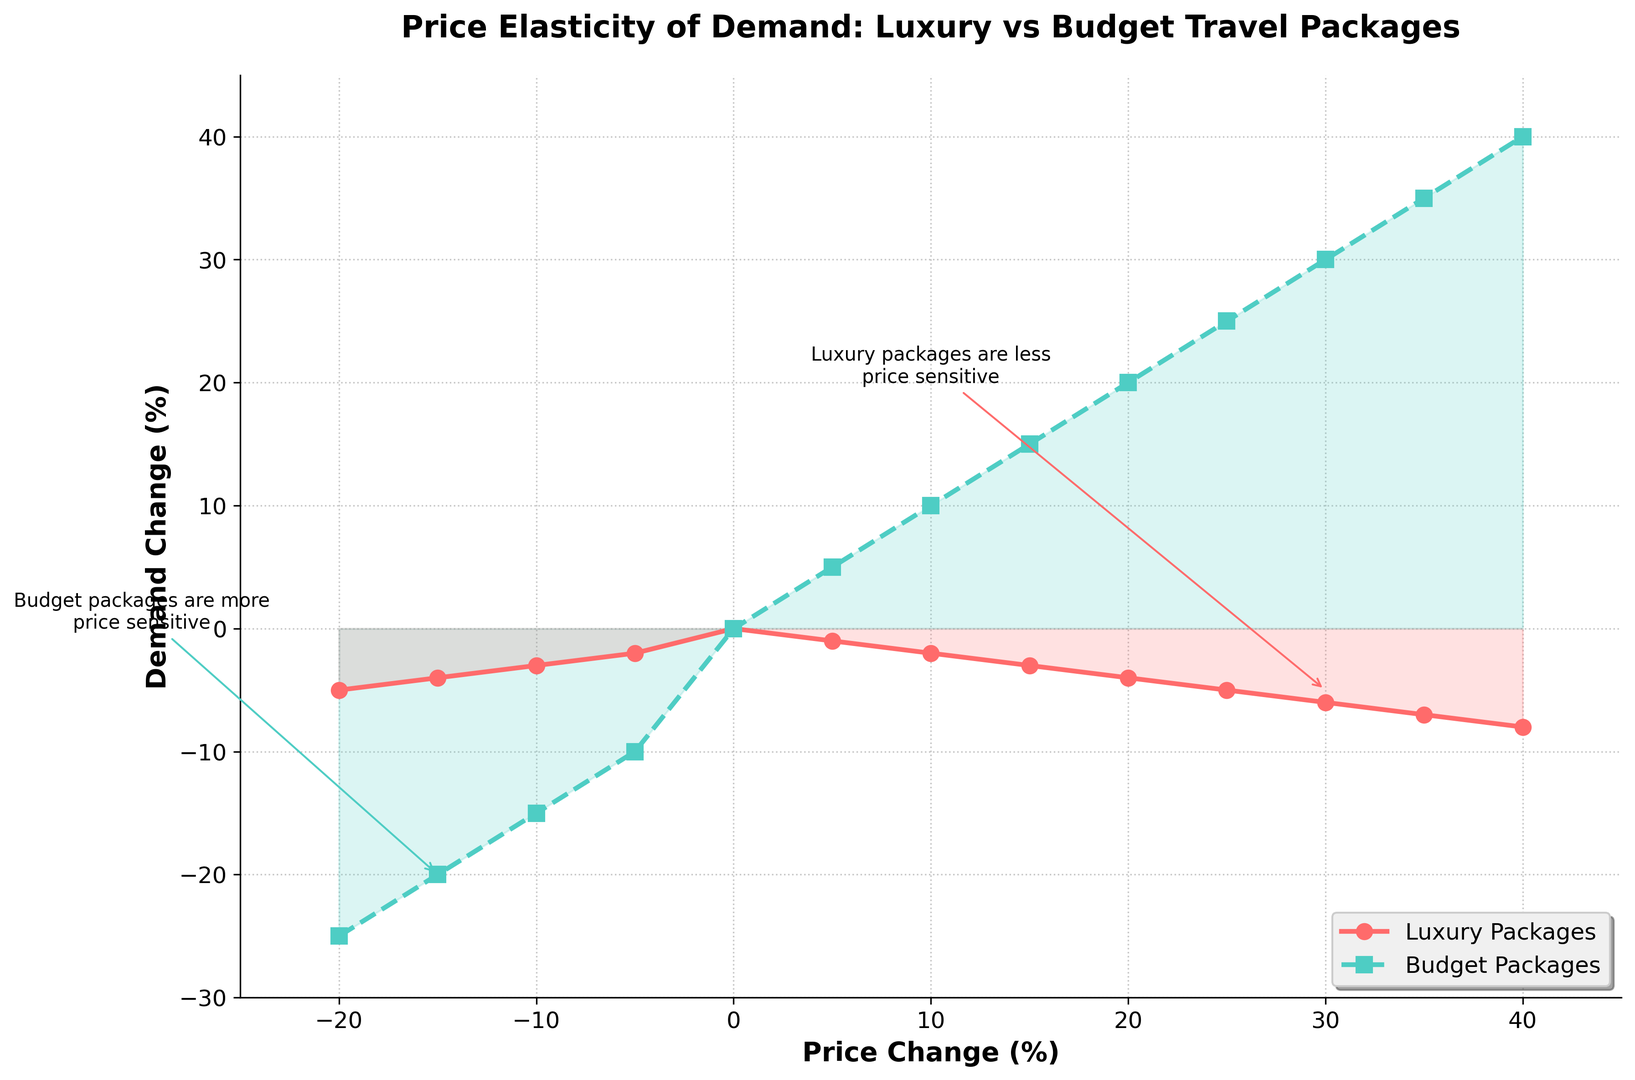What's the relationship between the price change and demand change for luxury packages? When the price change for luxury packages varies, the demand change tends to decrease linearly with it. For positive price changes, the luxury demand decreases, and for negative price changes, the decrease is more significant but also follows a linear trend.
Answer: Linear and decreasing Which type of travel package shows a higher sensitivity to price changes? By looking at the slopes, budget packages show more dramatic changes in demand in response to price changes, whereas luxury packages show slower changes. Specifically, each 5% price increase results in a 5% demand increase for budget packages compared to 1-2% changes in luxury demand.
Answer: Budget packages At what price change percentage do budget packages start showing an increase in demand? By examining the data points, budget packages show an increase in demand starting at a 5% price increase, while luxury packages continue to decrease in demand.
Answer: 5% How do demand changes differ at a 20% price increase between luxury and budget travel packages? For the 20% price increase, the luxury package demand change is -4%, while the budget package demand change is +20%, showing a clear contrast in price sensitivity.
Answer: -4% vs. +20% respectively Describe the intersection point where demand changes for both luxury and budget packages are zero. The intersection occurs at a 0% price change where both luxury and budget packages' demand changes are zero, indicating the baseline or equilibrium point for demand.
Answer: 0% If the price of luxury packages drops by 10%, what is the expected demand change, and how does it compare to budget packages? A 10% price drop results in a 3% decrease in luxury demand but results in a 15% decrease in budget demand. When compared, the budget package demand is much more sensitive to price decreases.
Answer: -3% for luxury, -15% for budget What does the annotation 'Luxury packages are less price sensitive' signify in the figure? The annotation denotes that luxury packages show smaller changes in demand with price fluctuations, which is highlighted at a 30% price change where the demand drop is minimal compared to budget packages.
Answer: Smaller demand changes Identify the range where budget packages show an increase in demand regardless of the price increase. Budget packages exhibit an unbroken rise in demand from a price increase of 5% up to 40%, showing a positive correlation between price increases and demand.
Answer: 5% to 40% What is the visual difference between the demand lines of luxury and budget packages? The luxury packages are represented by lines with circles and a solid line, which is red, while the budget packages are shown using squares and a dashed line, which is green. The luxury demand line consistently shows more minor changes compared to the steeper budget demand line.
Answer: Red solid line with circles vs. green dashed line with squares Between which price change percentages do luxury and budget demands intersect? The data implies that these curves never actually intersect; luxury demand remains consistently less sensitive than budget demand throughout the observed range. This indicates the stark contrast between their price elasticities.
Answer: They do not intersect 